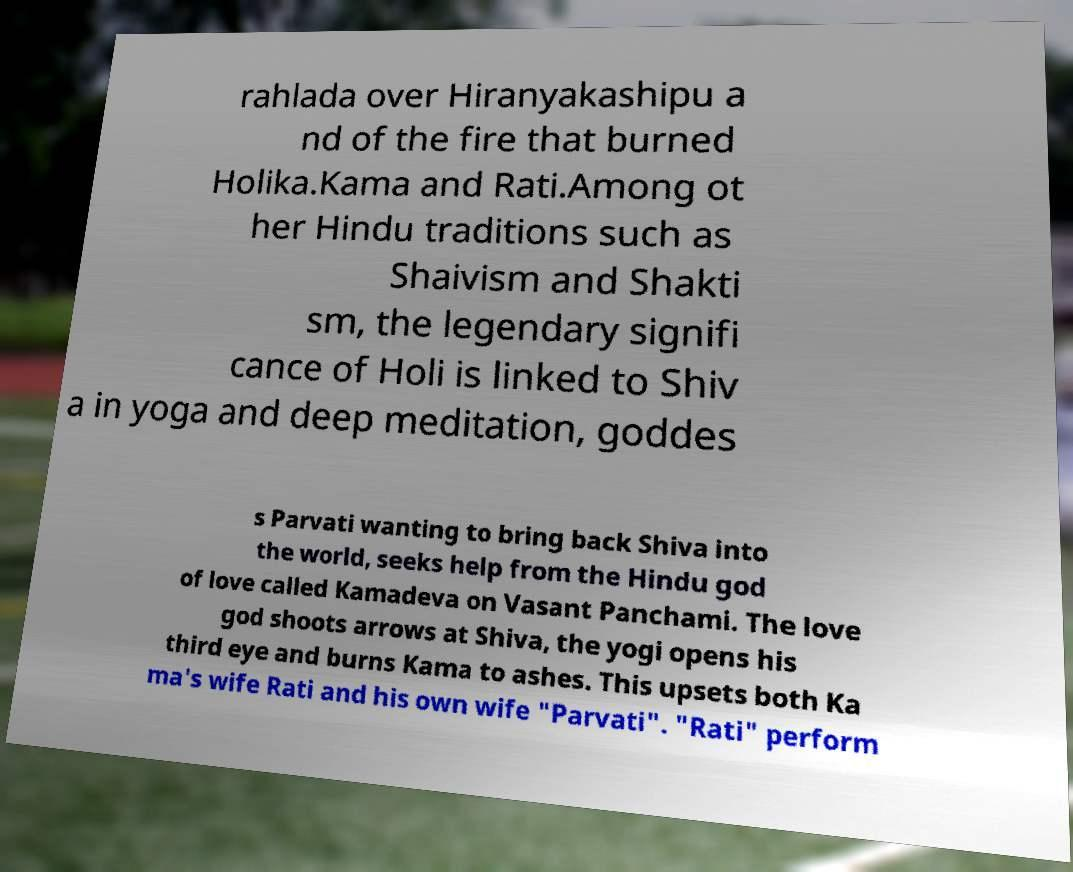Can you accurately transcribe the text from the provided image for me? rahlada over Hiranyakashipu a nd of the fire that burned Holika.Kama and Rati.Among ot her Hindu traditions such as Shaivism and Shakti sm, the legendary signifi cance of Holi is linked to Shiv a in yoga and deep meditation, goddes s Parvati wanting to bring back Shiva into the world, seeks help from the Hindu god of love called Kamadeva on Vasant Panchami. The love god shoots arrows at Shiva, the yogi opens his third eye and burns Kama to ashes. This upsets both Ka ma's wife Rati and his own wife "Parvati". "Rati" perform 